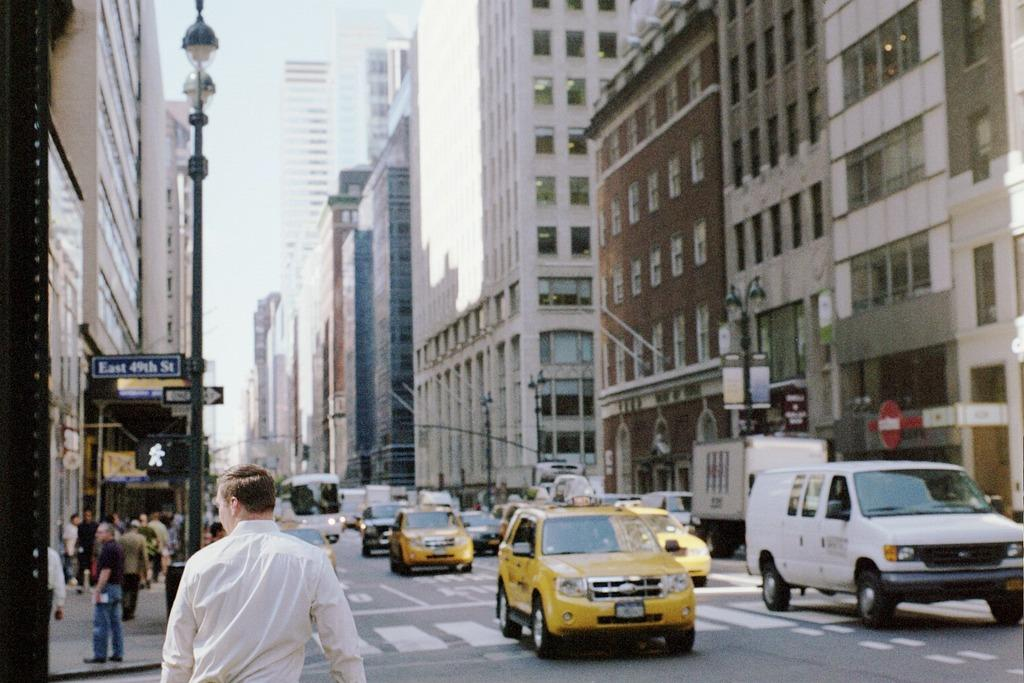<image>
Write a terse but informative summary of the picture. traffic with a taxi cab in front of a street sign that says East 49th street one way 